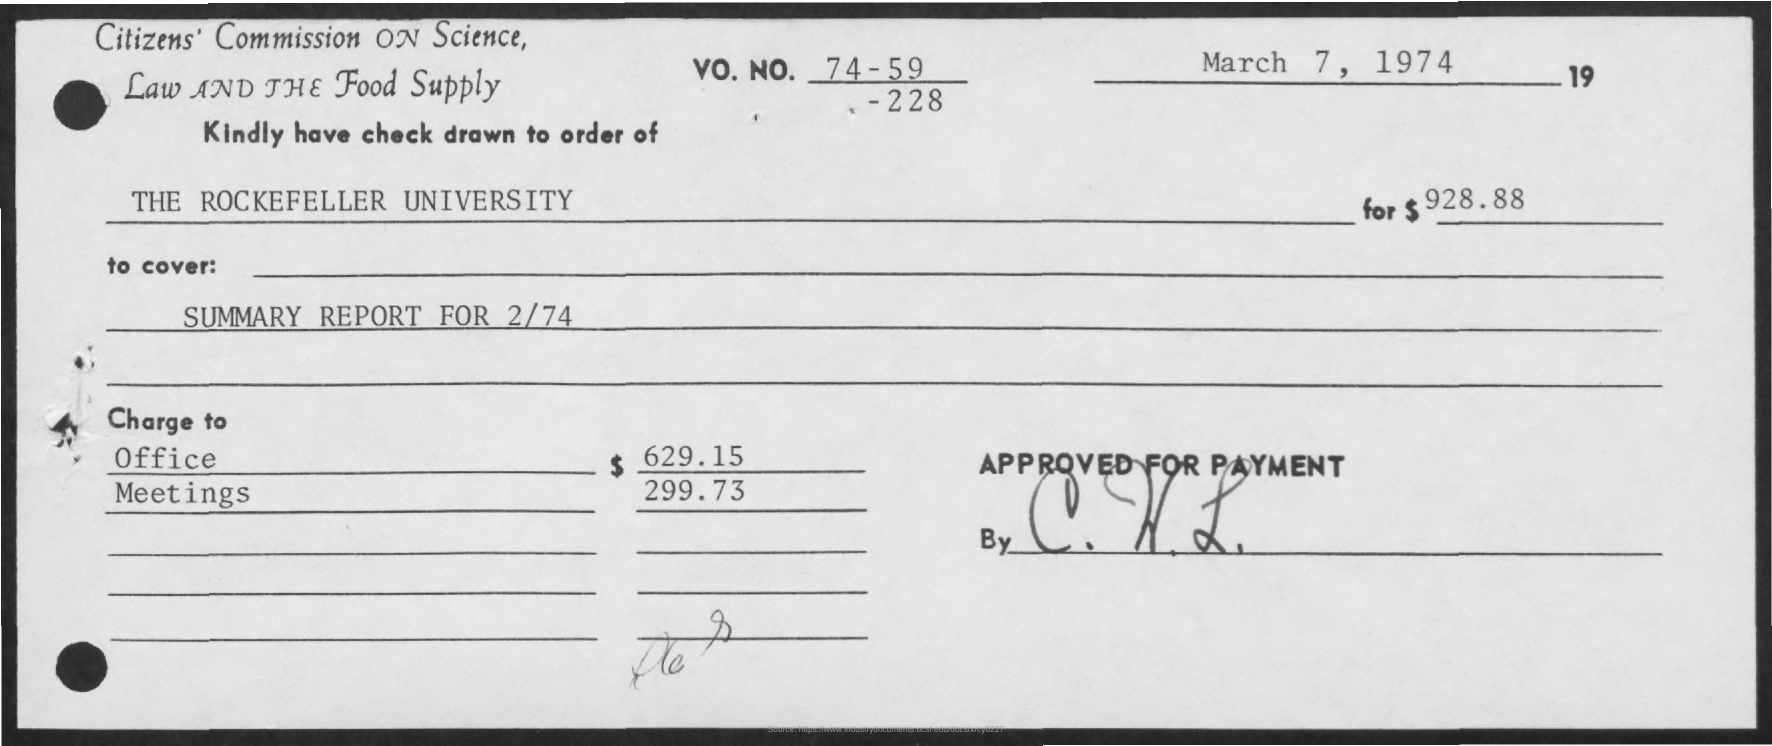Indicate a few pertinent items in this graphic. The date on the document is March 7, 1974. The summary report for February 1974 will provide a comprehensive overview of the covered topics. The Rockefeller University has issued a check, and it is being drawn to the order of? The charge for Office is $629.15. The VO. NO. is 74-59-228. 